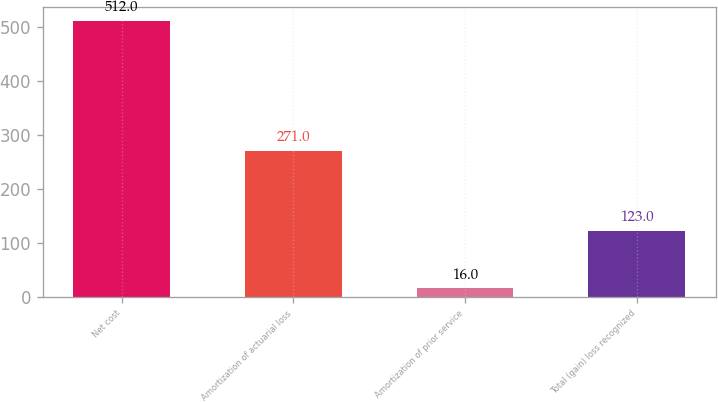Convert chart to OTSL. <chart><loc_0><loc_0><loc_500><loc_500><bar_chart><fcel>Net cost<fcel>Amortization of actuarial loss<fcel>Amortization of prior service<fcel>Total (gain) loss recognized<nl><fcel>512<fcel>271<fcel>16<fcel>123<nl></chart> 